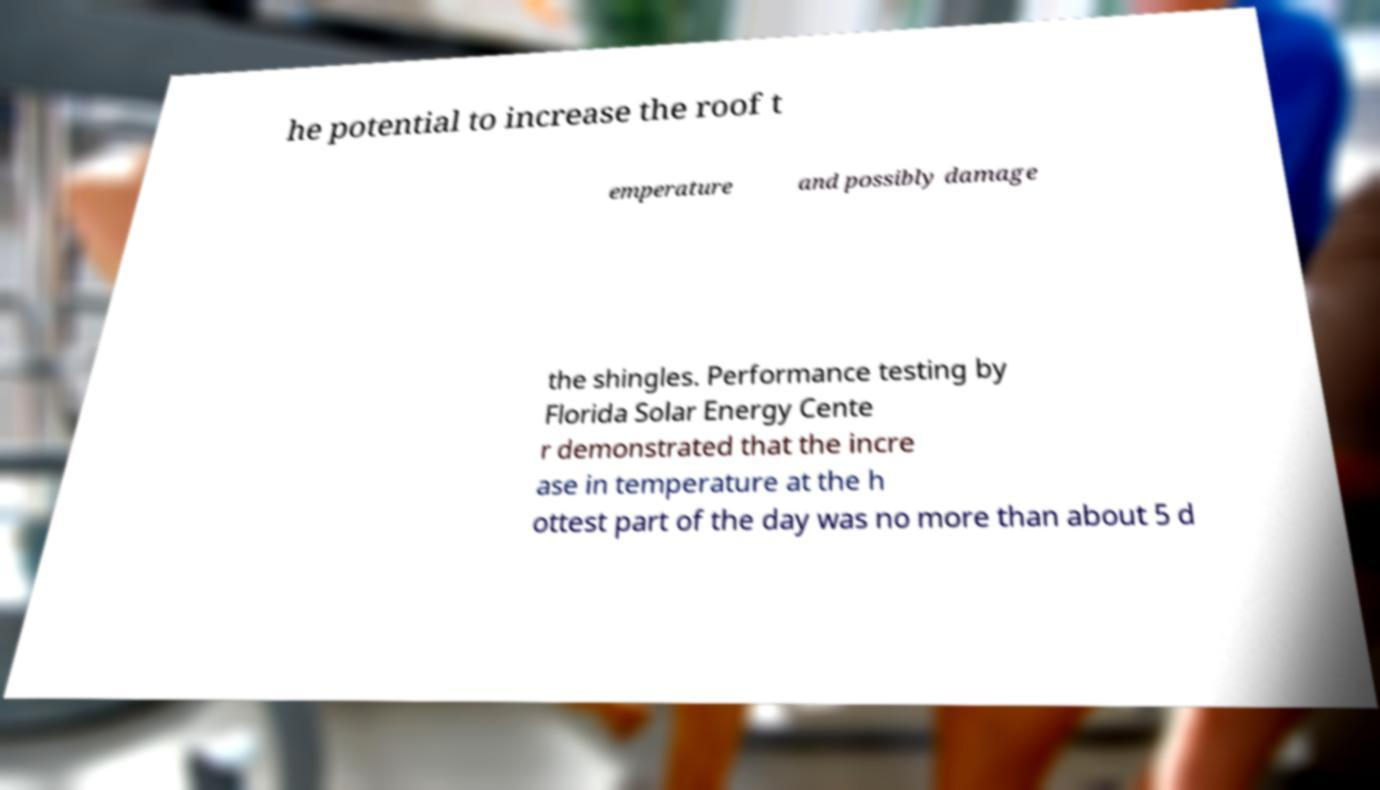I need the written content from this picture converted into text. Can you do that? he potential to increase the roof t emperature and possibly damage the shingles. Performance testing by Florida Solar Energy Cente r demonstrated that the incre ase in temperature at the h ottest part of the day was no more than about 5 d 